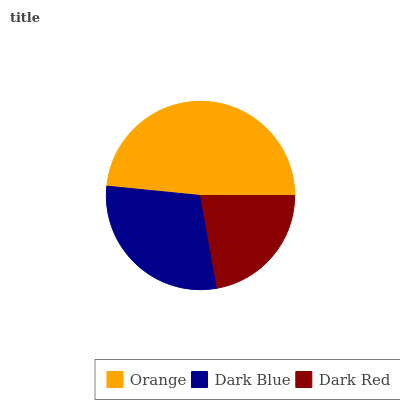Is Dark Red the minimum?
Answer yes or no. Yes. Is Orange the maximum?
Answer yes or no. Yes. Is Dark Blue the minimum?
Answer yes or no. No. Is Dark Blue the maximum?
Answer yes or no. No. Is Orange greater than Dark Blue?
Answer yes or no. Yes. Is Dark Blue less than Orange?
Answer yes or no. Yes. Is Dark Blue greater than Orange?
Answer yes or no. No. Is Orange less than Dark Blue?
Answer yes or no. No. Is Dark Blue the high median?
Answer yes or no. Yes. Is Dark Blue the low median?
Answer yes or no. Yes. Is Orange the high median?
Answer yes or no. No. Is Orange the low median?
Answer yes or no. No. 